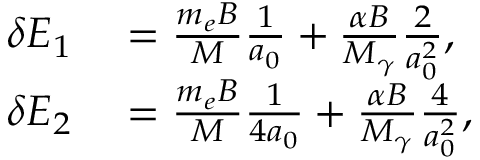Convert formula to latex. <formula><loc_0><loc_0><loc_500><loc_500>\begin{array} { r l } { \delta E _ { 1 } } & = \frac { m _ { e } B } { M } \frac { 1 } { a _ { 0 } } + \frac { \alpha B } { M _ { \gamma } } \frac { 2 } { a _ { 0 } ^ { 2 } } , } \\ { \delta E _ { 2 } } & = \frac { m _ { e } B } { M } \frac { 1 } { 4 a _ { 0 } } + \frac { \alpha B } { M _ { \gamma } } \frac { 4 } { a _ { 0 } ^ { 2 } } , } \end{array}</formula> 